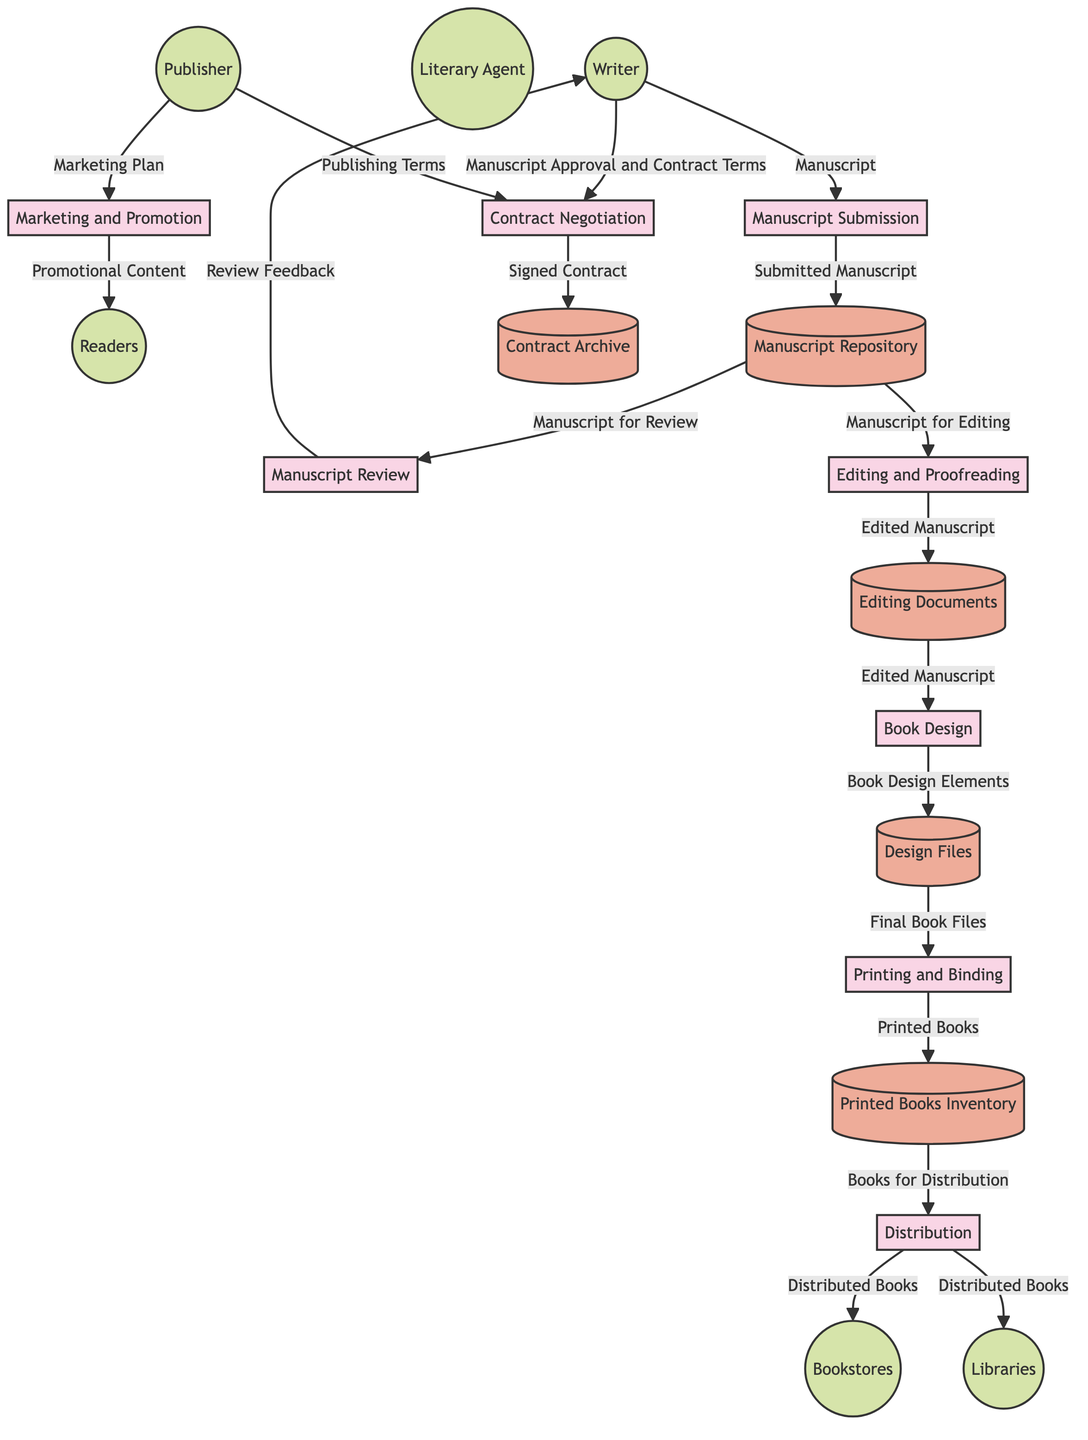What is the first process in the publishing flow? The first process in the publishing flow is "Manuscript Submission." This can be identified as it is the starting point where the writer submits their finished manuscript.
Answer: Manuscript Submission How many data stores are included in the diagram? By counting the items labeled as data stores, there are five data stores in total: Manuscript Repository, Contract Archive, Editing Documents, Design Files, and Printed Books Inventory.
Answer: 5 What type of entity is "Publisher"? "Publisher" is classified as an external entity in the diagram, specifically a company that handles various tasks in the publishing process including reviewing, editing, designing, and distributing the book.
Answer: external entity Which process involves both the Writer and Publisher? The process "Contract Negotiation" involves both the Writer and Publisher. The Writer discusses manuscript approval and contract terms, while the Publisher presents publishing terms.
Answer: Contract Negotiation What data flow occurs from "Editing and Proofreading" to "Editing Documents"? The data flow from "Editing and Proofreading" to "Editing Documents" is labeled as "Edited Manuscript." This shows that the edited version of the manuscript is stored as a separate document in the editing storage.
Answer: Edited Manuscript How many external entities are in the diagram? There are six external entities in the diagram: Writer, Literary Agent, Publisher, Bookstores, Libraries, and Readers.
Answer: 6 What is stored in the "Printed Books Inventory"? The "Printed Books Inventory" is where the "Printed Books" are stored, indicating that these are the physical copies prepared for distribution.
Answer: Printed Books Which process follows immediately after "Book Design"? The process that follows immediately after "Book Design" is "Printing and Binding," where the final versions of the book files are printed and bound for distribution.
Answer: Printing and Binding What type of data is transferred from "Distribution" to "Bookstores"? The type of data transferred from "Distribution" to "Bookstores" is labeled as "Distributed Books," signifying the books that are sent to various retail outlets for sale.
Answer: Distributed Books 